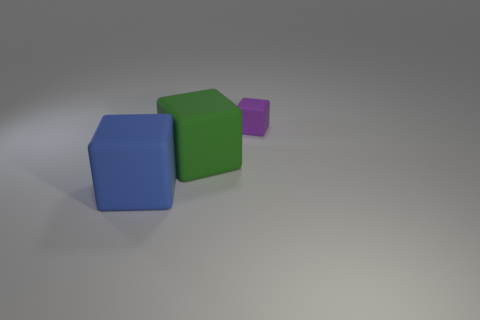Subtract 1 blocks. How many blocks are left? 2 Add 2 large gray matte cylinders. How many objects exist? 5 Subtract all blue matte objects. Subtract all purple rubber things. How many objects are left? 1 Add 2 blue blocks. How many blue blocks are left? 3 Add 3 large green matte cubes. How many large green matte cubes exist? 4 Subtract 0 blue spheres. How many objects are left? 3 